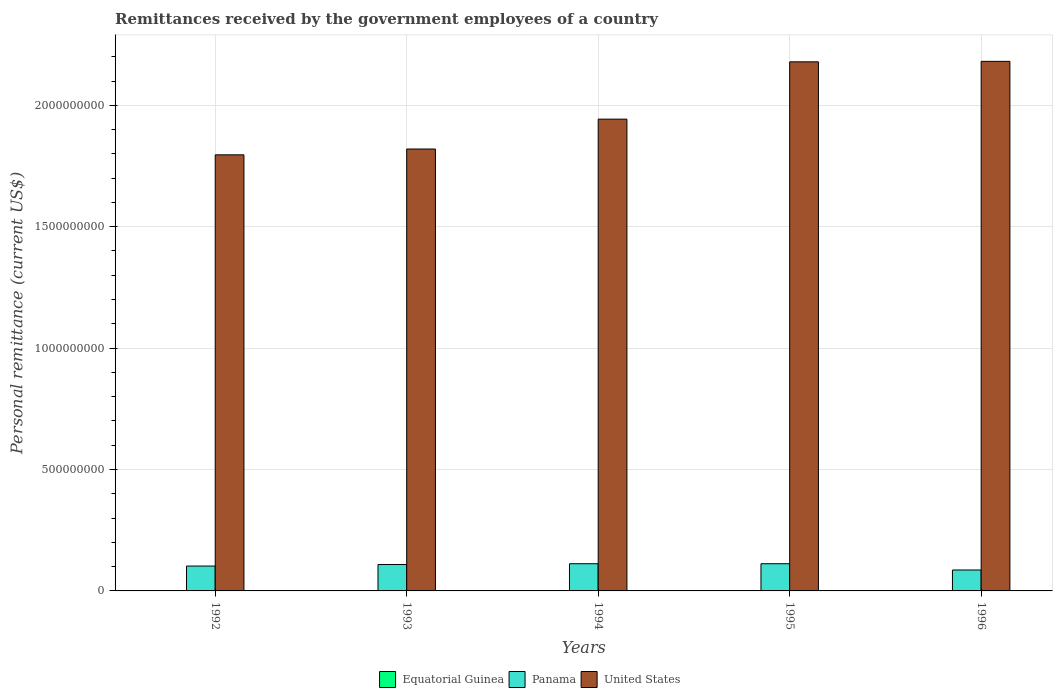How many different coloured bars are there?
Offer a very short reply. 3. Are the number of bars on each tick of the X-axis equal?
Offer a terse response. Yes. How many bars are there on the 1st tick from the left?
Keep it short and to the point. 3. What is the label of the 5th group of bars from the left?
Your response must be concise. 1996. What is the remittances received by the government employees in United States in 1995?
Your answer should be compact. 2.18e+09. Across all years, what is the maximum remittances received by the government employees in Equatorial Guinea?
Your answer should be very brief. 1.32e+06. Across all years, what is the minimum remittances received by the government employees in Panama?
Your response must be concise. 8.62e+07. In which year was the remittances received by the government employees in Equatorial Guinea maximum?
Make the answer very short. 1992. In which year was the remittances received by the government employees in Panama minimum?
Offer a terse response. 1996. What is the total remittances received by the government employees in United States in the graph?
Keep it short and to the point. 9.92e+09. What is the difference between the remittances received by the government employees in Panama in 1994 and that in 1996?
Your answer should be very brief. 2.58e+07. What is the difference between the remittances received by the government employees in Equatorial Guinea in 1996 and the remittances received by the government employees in Panama in 1995?
Give a very brief answer. -1.12e+08. What is the average remittances received by the government employees in United States per year?
Provide a short and direct response. 1.98e+09. In the year 1994, what is the difference between the remittances received by the government employees in United States and remittances received by the government employees in Panama?
Offer a very short reply. 1.83e+09. What is the ratio of the remittances received by the government employees in Equatorial Guinea in 1993 to that in 1995?
Give a very brief answer. 9.11. What is the difference between the highest and the second highest remittances received by the government employees in Panama?
Give a very brief answer. 0. What is the difference between the highest and the lowest remittances received by the government employees in United States?
Give a very brief answer. 3.85e+08. In how many years, is the remittances received by the government employees in Panama greater than the average remittances received by the government employees in Panama taken over all years?
Make the answer very short. 3. Is the sum of the remittances received by the government employees in Equatorial Guinea in 1994 and 1996 greater than the maximum remittances received by the government employees in United States across all years?
Offer a terse response. No. What does the 1st bar from the left in 1992 represents?
Ensure brevity in your answer.  Equatorial Guinea. Is it the case that in every year, the sum of the remittances received by the government employees in Panama and remittances received by the government employees in Equatorial Guinea is greater than the remittances received by the government employees in United States?
Make the answer very short. No. Are all the bars in the graph horizontal?
Your answer should be compact. No. How many years are there in the graph?
Your response must be concise. 5. What is the difference between two consecutive major ticks on the Y-axis?
Provide a short and direct response. 5.00e+08. Are the values on the major ticks of Y-axis written in scientific E-notation?
Make the answer very short. No. Does the graph contain grids?
Your response must be concise. Yes. How are the legend labels stacked?
Keep it short and to the point. Horizontal. What is the title of the graph?
Offer a very short reply. Remittances received by the government employees of a country. Does "Georgia" appear as one of the legend labels in the graph?
Your response must be concise. No. What is the label or title of the X-axis?
Offer a very short reply. Years. What is the label or title of the Y-axis?
Offer a very short reply. Personal remittance (current US$). What is the Personal remittance (current US$) of Equatorial Guinea in 1992?
Ensure brevity in your answer.  1.32e+06. What is the Personal remittance (current US$) in Panama in 1992?
Your response must be concise. 1.02e+08. What is the Personal remittance (current US$) in United States in 1992?
Your answer should be compact. 1.80e+09. What is the Personal remittance (current US$) in Equatorial Guinea in 1993?
Give a very brief answer. 9.12e+05. What is the Personal remittance (current US$) in Panama in 1993?
Keep it short and to the point. 1.09e+08. What is the Personal remittance (current US$) in United States in 1993?
Your response must be concise. 1.82e+09. What is the Personal remittance (current US$) in Equatorial Guinea in 1994?
Provide a succinct answer. 5.06e+05. What is the Personal remittance (current US$) in Panama in 1994?
Your answer should be very brief. 1.12e+08. What is the Personal remittance (current US$) of United States in 1994?
Your response must be concise. 1.94e+09. What is the Personal remittance (current US$) in Equatorial Guinea in 1995?
Keep it short and to the point. 1.00e+05. What is the Personal remittance (current US$) of Panama in 1995?
Provide a succinct answer. 1.12e+08. What is the Personal remittance (current US$) of United States in 1995?
Keep it short and to the point. 2.18e+09. What is the Personal remittance (current US$) in Equatorial Guinea in 1996?
Your response must be concise. 1.64e+05. What is the Personal remittance (current US$) in Panama in 1996?
Offer a terse response. 8.62e+07. What is the Personal remittance (current US$) of United States in 1996?
Make the answer very short. 2.18e+09. Across all years, what is the maximum Personal remittance (current US$) of Equatorial Guinea?
Your response must be concise. 1.32e+06. Across all years, what is the maximum Personal remittance (current US$) in Panama?
Offer a terse response. 1.12e+08. Across all years, what is the maximum Personal remittance (current US$) in United States?
Provide a succinct answer. 2.18e+09. Across all years, what is the minimum Personal remittance (current US$) of Equatorial Guinea?
Keep it short and to the point. 1.00e+05. Across all years, what is the minimum Personal remittance (current US$) of Panama?
Keep it short and to the point. 8.62e+07. Across all years, what is the minimum Personal remittance (current US$) in United States?
Make the answer very short. 1.80e+09. What is the total Personal remittance (current US$) of Equatorial Guinea in the graph?
Give a very brief answer. 3.00e+06. What is the total Personal remittance (current US$) of Panama in the graph?
Provide a short and direct response. 5.21e+08. What is the total Personal remittance (current US$) in United States in the graph?
Your answer should be very brief. 9.92e+09. What is the difference between the Personal remittance (current US$) of Equatorial Guinea in 1992 and that in 1993?
Provide a short and direct response. 4.06e+05. What is the difference between the Personal remittance (current US$) in Panama in 1992 and that in 1993?
Your answer should be very brief. -6.30e+06. What is the difference between the Personal remittance (current US$) in United States in 1992 and that in 1993?
Make the answer very short. -2.40e+07. What is the difference between the Personal remittance (current US$) in Equatorial Guinea in 1992 and that in 1994?
Your answer should be compact. 8.12e+05. What is the difference between the Personal remittance (current US$) of Panama in 1992 and that in 1994?
Keep it short and to the point. -9.60e+06. What is the difference between the Personal remittance (current US$) of United States in 1992 and that in 1994?
Offer a terse response. -1.47e+08. What is the difference between the Personal remittance (current US$) of Equatorial Guinea in 1992 and that in 1995?
Your answer should be very brief. 1.22e+06. What is the difference between the Personal remittance (current US$) of Panama in 1992 and that in 1995?
Offer a very short reply. -9.60e+06. What is the difference between the Personal remittance (current US$) in United States in 1992 and that in 1995?
Offer a terse response. -3.83e+08. What is the difference between the Personal remittance (current US$) in Equatorial Guinea in 1992 and that in 1996?
Your answer should be compact. 1.15e+06. What is the difference between the Personal remittance (current US$) in Panama in 1992 and that in 1996?
Your answer should be very brief. 1.62e+07. What is the difference between the Personal remittance (current US$) in United States in 1992 and that in 1996?
Provide a short and direct response. -3.85e+08. What is the difference between the Personal remittance (current US$) in Equatorial Guinea in 1993 and that in 1994?
Ensure brevity in your answer.  4.06e+05. What is the difference between the Personal remittance (current US$) in Panama in 1993 and that in 1994?
Your response must be concise. -3.30e+06. What is the difference between the Personal remittance (current US$) in United States in 1993 and that in 1994?
Provide a succinct answer. -1.23e+08. What is the difference between the Personal remittance (current US$) in Equatorial Guinea in 1993 and that in 1995?
Your response must be concise. 8.12e+05. What is the difference between the Personal remittance (current US$) of Panama in 1993 and that in 1995?
Keep it short and to the point. -3.30e+06. What is the difference between the Personal remittance (current US$) of United States in 1993 and that in 1995?
Provide a short and direct response. -3.59e+08. What is the difference between the Personal remittance (current US$) of Equatorial Guinea in 1993 and that in 1996?
Give a very brief answer. 7.48e+05. What is the difference between the Personal remittance (current US$) in Panama in 1993 and that in 1996?
Keep it short and to the point. 2.25e+07. What is the difference between the Personal remittance (current US$) in United States in 1993 and that in 1996?
Offer a very short reply. -3.61e+08. What is the difference between the Personal remittance (current US$) of Equatorial Guinea in 1994 and that in 1995?
Keep it short and to the point. 4.06e+05. What is the difference between the Personal remittance (current US$) of Panama in 1994 and that in 1995?
Offer a terse response. 0. What is the difference between the Personal remittance (current US$) in United States in 1994 and that in 1995?
Your answer should be very brief. -2.36e+08. What is the difference between the Personal remittance (current US$) of Equatorial Guinea in 1994 and that in 1996?
Your answer should be very brief. 3.42e+05. What is the difference between the Personal remittance (current US$) in Panama in 1994 and that in 1996?
Ensure brevity in your answer.  2.58e+07. What is the difference between the Personal remittance (current US$) of United States in 1994 and that in 1996?
Give a very brief answer. -2.38e+08. What is the difference between the Personal remittance (current US$) of Equatorial Guinea in 1995 and that in 1996?
Your answer should be very brief. -6.40e+04. What is the difference between the Personal remittance (current US$) of Panama in 1995 and that in 1996?
Keep it short and to the point. 2.58e+07. What is the difference between the Personal remittance (current US$) in United States in 1995 and that in 1996?
Provide a succinct answer. -2.00e+06. What is the difference between the Personal remittance (current US$) in Equatorial Guinea in 1992 and the Personal remittance (current US$) in Panama in 1993?
Your response must be concise. -1.07e+08. What is the difference between the Personal remittance (current US$) in Equatorial Guinea in 1992 and the Personal remittance (current US$) in United States in 1993?
Offer a very short reply. -1.82e+09. What is the difference between the Personal remittance (current US$) of Panama in 1992 and the Personal remittance (current US$) of United States in 1993?
Make the answer very short. -1.72e+09. What is the difference between the Personal remittance (current US$) in Equatorial Guinea in 1992 and the Personal remittance (current US$) in Panama in 1994?
Offer a very short reply. -1.11e+08. What is the difference between the Personal remittance (current US$) of Equatorial Guinea in 1992 and the Personal remittance (current US$) of United States in 1994?
Keep it short and to the point. -1.94e+09. What is the difference between the Personal remittance (current US$) of Panama in 1992 and the Personal remittance (current US$) of United States in 1994?
Your response must be concise. -1.84e+09. What is the difference between the Personal remittance (current US$) of Equatorial Guinea in 1992 and the Personal remittance (current US$) of Panama in 1995?
Offer a very short reply. -1.11e+08. What is the difference between the Personal remittance (current US$) of Equatorial Guinea in 1992 and the Personal remittance (current US$) of United States in 1995?
Keep it short and to the point. -2.18e+09. What is the difference between the Personal remittance (current US$) in Panama in 1992 and the Personal remittance (current US$) in United States in 1995?
Offer a very short reply. -2.08e+09. What is the difference between the Personal remittance (current US$) of Equatorial Guinea in 1992 and the Personal remittance (current US$) of Panama in 1996?
Offer a terse response. -8.49e+07. What is the difference between the Personal remittance (current US$) of Equatorial Guinea in 1992 and the Personal remittance (current US$) of United States in 1996?
Offer a terse response. -2.18e+09. What is the difference between the Personal remittance (current US$) in Panama in 1992 and the Personal remittance (current US$) in United States in 1996?
Offer a terse response. -2.08e+09. What is the difference between the Personal remittance (current US$) in Equatorial Guinea in 1993 and the Personal remittance (current US$) in Panama in 1994?
Ensure brevity in your answer.  -1.11e+08. What is the difference between the Personal remittance (current US$) of Equatorial Guinea in 1993 and the Personal remittance (current US$) of United States in 1994?
Offer a terse response. -1.94e+09. What is the difference between the Personal remittance (current US$) in Panama in 1993 and the Personal remittance (current US$) in United States in 1994?
Offer a terse response. -1.83e+09. What is the difference between the Personal remittance (current US$) of Equatorial Guinea in 1993 and the Personal remittance (current US$) of Panama in 1995?
Make the answer very short. -1.11e+08. What is the difference between the Personal remittance (current US$) of Equatorial Guinea in 1993 and the Personal remittance (current US$) of United States in 1995?
Your answer should be compact. -2.18e+09. What is the difference between the Personal remittance (current US$) in Panama in 1993 and the Personal remittance (current US$) in United States in 1995?
Your answer should be compact. -2.07e+09. What is the difference between the Personal remittance (current US$) in Equatorial Guinea in 1993 and the Personal remittance (current US$) in Panama in 1996?
Offer a terse response. -8.53e+07. What is the difference between the Personal remittance (current US$) of Equatorial Guinea in 1993 and the Personal remittance (current US$) of United States in 1996?
Offer a terse response. -2.18e+09. What is the difference between the Personal remittance (current US$) of Panama in 1993 and the Personal remittance (current US$) of United States in 1996?
Keep it short and to the point. -2.07e+09. What is the difference between the Personal remittance (current US$) of Equatorial Guinea in 1994 and the Personal remittance (current US$) of Panama in 1995?
Your answer should be compact. -1.11e+08. What is the difference between the Personal remittance (current US$) of Equatorial Guinea in 1994 and the Personal remittance (current US$) of United States in 1995?
Offer a very short reply. -2.18e+09. What is the difference between the Personal remittance (current US$) in Panama in 1994 and the Personal remittance (current US$) in United States in 1995?
Make the answer very short. -2.07e+09. What is the difference between the Personal remittance (current US$) in Equatorial Guinea in 1994 and the Personal remittance (current US$) in Panama in 1996?
Offer a very short reply. -8.57e+07. What is the difference between the Personal remittance (current US$) in Equatorial Guinea in 1994 and the Personal remittance (current US$) in United States in 1996?
Keep it short and to the point. -2.18e+09. What is the difference between the Personal remittance (current US$) in Panama in 1994 and the Personal remittance (current US$) in United States in 1996?
Ensure brevity in your answer.  -2.07e+09. What is the difference between the Personal remittance (current US$) of Equatorial Guinea in 1995 and the Personal remittance (current US$) of Panama in 1996?
Provide a succinct answer. -8.61e+07. What is the difference between the Personal remittance (current US$) in Equatorial Guinea in 1995 and the Personal remittance (current US$) in United States in 1996?
Your answer should be very brief. -2.18e+09. What is the difference between the Personal remittance (current US$) of Panama in 1995 and the Personal remittance (current US$) of United States in 1996?
Your answer should be very brief. -2.07e+09. What is the average Personal remittance (current US$) of Equatorial Guinea per year?
Your answer should be compact. 6.00e+05. What is the average Personal remittance (current US$) of Panama per year?
Give a very brief answer. 1.04e+08. What is the average Personal remittance (current US$) of United States per year?
Provide a succinct answer. 1.98e+09. In the year 1992, what is the difference between the Personal remittance (current US$) of Equatorial Guinea and Personal remittance (current US$) of Panama?
Ensure brevity in your answer.  -1.01e+08. In the year 1992, what is the difference between the Personal remittance (current US$) of Equatorial Guinea and Personal remittance (current US$) of United States?
Offer a terse response. -1.79e+09. In the year 1992, what is the difference between the Personal remittance (current US$) of Panama and Personal remittance (current US$) of United States?
Make the answer very short. -1.69e+09. In the year 1993, what is the difference between the Personal remittance (current US$) of Equatorial Guinea and Personal remittance (current US$) of Panama?
Your response must be concise. -1.08e+08. In the year 1993, what is the difference between the Personal remittance (current US$) in Equatorial Guinea and Personal remittance (current US$) in United States?
Make the answer very short. -1.82e+09. In the year 1993, what is the difference between the Personal remittance (current US$) of Panama and Personal remittance (current US$) of United States?
Offer a very short reply. -1.71e+09. In the year 1994, what is the difference between the Personal remittance (current US$) of Equatorial Guinea and Personal remittance (current US$) of Panama?
Offer a very short reply. -1.11e+08. In the year 1994, what is the difference between the Personal remittance (current US$) in Equatorial Guinea and Personal remittance (current US$) in United States?
Ensure brevity in your answer.  -1.94e+09. In the year 1994, what is the difference between the Personal remittance (current US$) in Panama and Personal remittance (current US$) in United States?
Offer a terse response. -1.83e+09. In the year 1995, what is the difference between the Personal remittance (current US$) of Equatorial Guinea and Personal remittance (current US$) of Panama?
Your response must be concise. -1.12e+08. In the year 1995, what is the difference between the Personal remittance (current US$) of Equatorial Guinea and Personal remittance (current US$) of United States?
Give a very brief answer. -2.18e+09. In the year 1995, what is the difference between the Personal remittance (current US$) in Panama and Personal remittance (current US$) in United States?
Provide a succinct answer. -2.07e+09. In the year 1996, what is the difference between the Personal remittance (current US$) in Equatorial Guinea and Personal remittance (current US$) in Panama?
Your answer should be very brief. -8.60e+07. In the year 1996, what is the difference between the Personal remittance (current US$) of Equatorial Guinea and Personal remittance (current US$) of United States?
Keep it short and to the point. -2.18e+09. In the year 1996, what is the difference between the Personal remittance (current US$) in Panama and Personal remittance (current US$) in United States?
Your answer should be compact. -2.09e+09. What is the ratio of the Personal remittance (current US$) of Equatorial Guinea in 1992 to that in 1993?
Offer a terse response. 1.45. What is the ratio of the Personal remittance (current US$) in Panama in 1992 to that in 1993?
Provide a short and direct response. 0.94. What is the ratio of the Personal remittance (current US$) in United States in 1992 to that in 1993?
Make the answer very short. 0.99. What is the ratio of the Personal remittance (current US$) of Equatorial Guinea in 1992 to that in 1994?
Provide a succinct answer. 2.6. What is the ratio of the Personal remittance (current US$) of Panama in 1992 to that in 1994?
Keep it short and to the point. 0.91. What is the ratio of the Personal remittance (current US$) in United States in 1992 to that in 1994?
Keep it short and to the point. 0.92. What is the ratio of the Personal remittance (current US$) of Equatorial Guinea in 1992 to that in 1995?
Keep it short and to the point. 13.16. What is the ratio of the Personal remittance (current US$) in Panama in 1992 to that in 1995?
Offer a very short reply. 0.91. What is the ratio of the Personal remittance (current US$) in United States in 1992 to that in 1995?
Make the answer very short. 0.82. What is the ratio of the Personal remittance (current US$) in Equatorial Guinea in 1992 to that in 1996?
Your response must be concise. 8.03. What is the ratio of the Personal remittance (current US$) of Panama in 1992 to that in 1996?
Give a very brief answer. 1.19. What is the ratio of the Personal remittance (current US$) of United States in 1992 to that in 1996?
Provide a succinct answer. 0.82. What is the ratio of the Personal remittance (current US$) of Equatorial Guinea in 1993 to that in 1994?
Provide a short and direct response. 1.8. What is the ratio of the Personal remittance (current US$) in Panama in 1993 to that in 1994?
Offer a very short reply. 0.97. What is the ratio of the Personal remittance (current US$) of United States in 1993 to that in 1994?
Provide a short and direct response. 0.94. What is the ratio of the Personal remittance (current US$) of Equatorial Guinea in 1993 to that in 1995?
Provide a short and direct response. 9.11. What is the ratio of the Personal remittance (current US$) in Panama in 1993 to that in 1995?
Your answer should be compact. 0.97. What is the ratio of the Personal remittance (current US$) of United States in 1993 to that in 1995?
Provide a short and direct response. 0.84. What is the ratio of the Personal remittance (current US$) of Equatorial Guinea in 1993 to that in 1996?
Keep it short and to the point. 5.56. What is the ratio of the Personal remittance (current US$) of Panama in 1993 to that in 1996?
Offer a terse response. 1.26. What is the ratio of the Personal remittance (current US$) of United States in 1993 to that in 1996?
Make the answer very short. 0.83. What is the ratio of the Personal remittance (current US$) in Equatorial Guinea in 1994 to that in 1995?
Ensure brevity in your answer.  5.05. What is the ratio of the Personal remittance (current US$) of Panama in 1994 to that in 1995?
Provide a succinct answer. 1. What is the ratio of the Personal remittance (current US$) of United States in 1994 to that in 1995?
Provide a short and direct response. 0.89. What is the ratio of the Personal remittance (current US$) of Equatorial Guinea in 1994 to that in 1996?
Your answer should be compact. 3.08. What is the ratio of the Personal remittance (current US$) of Panama in 1994 to that in 1996?
Provide a succinct answer. 1.3. What is the ratio of the Personal remittance (current US$) of United States in 1994 to that in 1996?
Your response must be concise. 0.89. What is the ratio of the Personal remittance (current US$) in Equatorial Guinea in 1995 to that in 1996?
Give a very brief answer. 0.61. What is the ratio of the Personal remittance (current US$) in Panama in 1995 to that in 1996?
Make the answer very short. 1.3. What is the difference between the highest and the second highest Personal remittance (current US$) of Equatorial Guinea?
Your response must be concise. 4.06e+05. What is the difference between the highest and the second highest Personal remittance (current US$) in United States?
Your answer should be compact. 2.00e+06. What is the difference between the highest and the lowest Personal remittance (current US$) in Equatorial Guinea?
Offer a very short reply. 1.22e+06. What is the difference between the highest and the lowest Personal remittance (current US$) of Panama?
Offer a very short reply. 2.58e+07. What is the difference between the highest and the lowest Personal remittance (current US$) of United States?
Provide a succinct answer. 3.85e+08. 